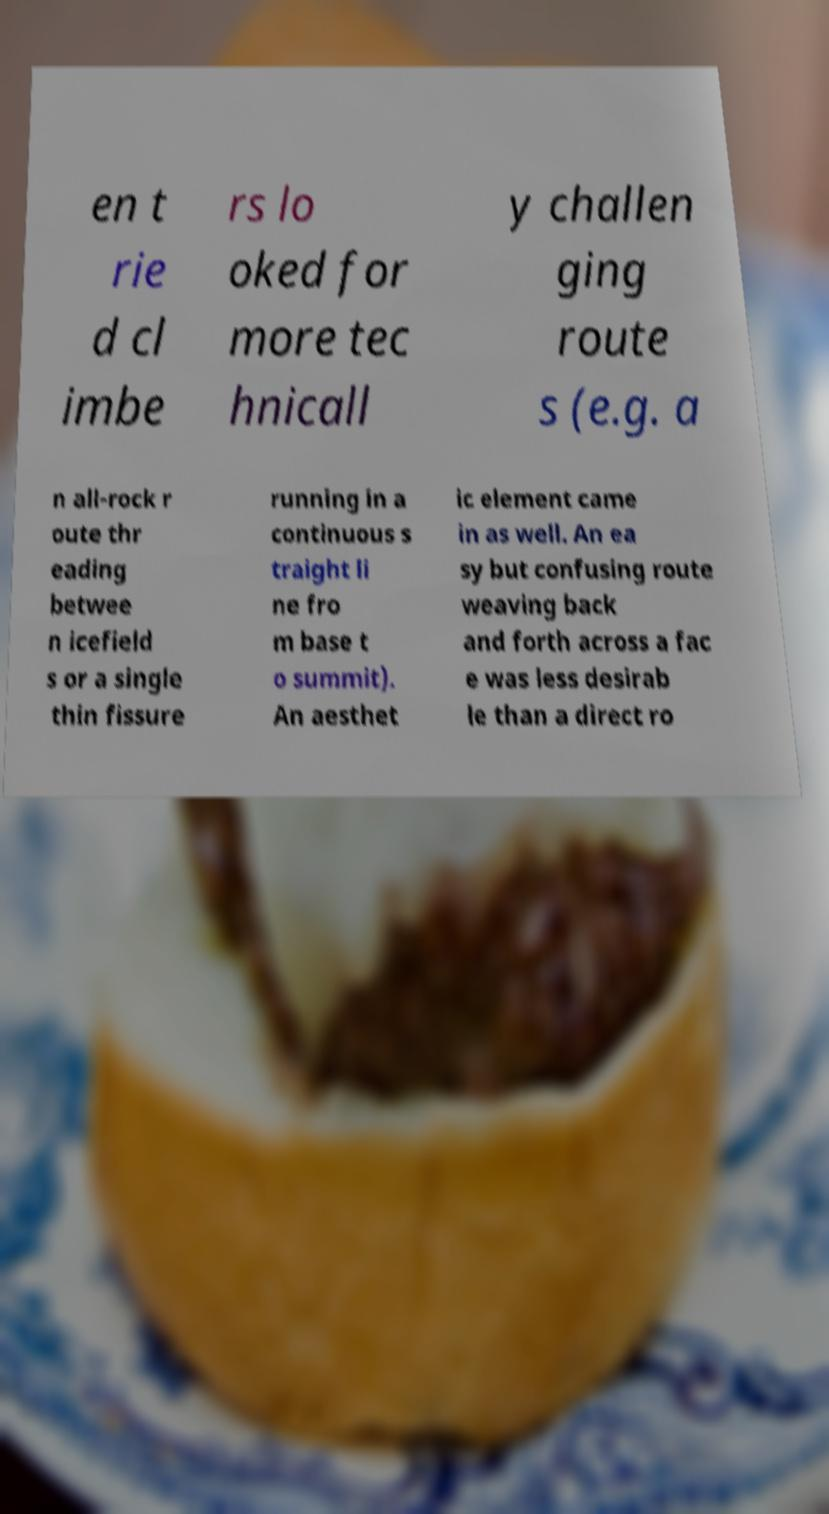I need the written content from this picture converted into text. Can you do that? en t rie d cl imbe rs lo oked for more tec hnicall y challen ging route s (e.g. a n all-rock r oute thr eading betwee n icefield s or a single thin fissure running in a continuous s traight li ne fro m base t o summit). An aesthet ic element came in as well. An ea sy but confusing route weaving back and forth across a fac e was less desirab le than a direct ro 